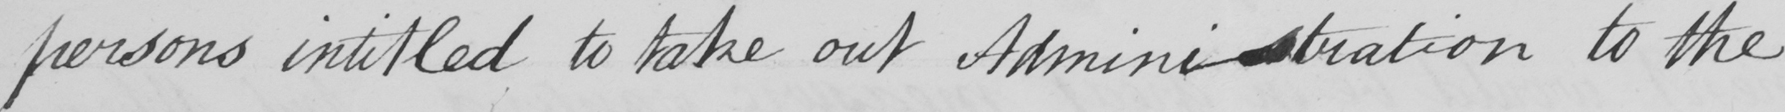Transcribe the text shown in this historical manuscript line. persons intitled to take out Administration to the 